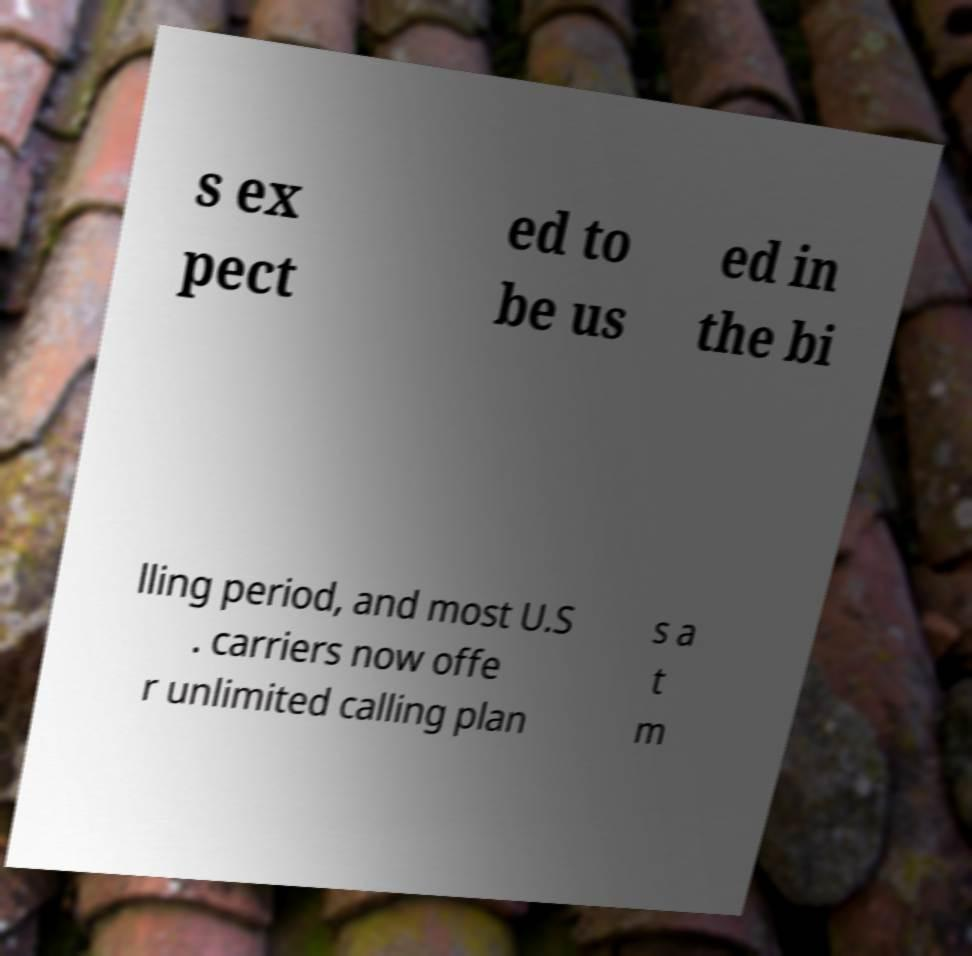I need the written content from this picture converted into text. Can you do that? s ex pect ed to be us ed in the bi lling period, and most U.S . carriers now offe r unlimited calling plan s a t m 